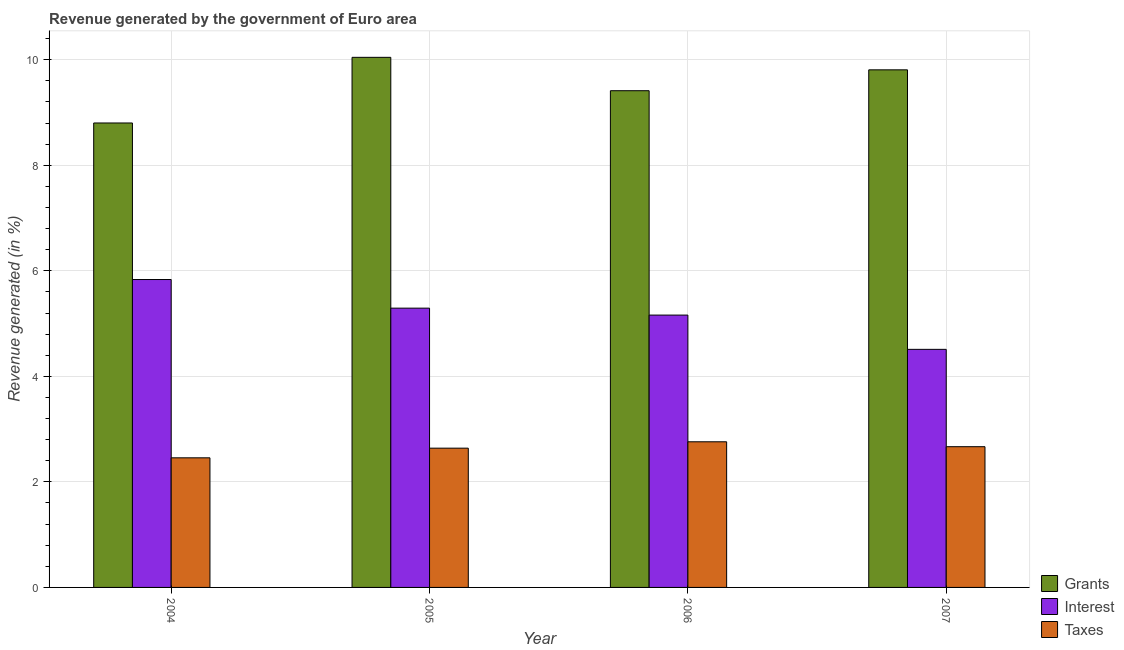What is the label of the 2nd group of bars from the left?
Make the answer very short. 2005. In how many cases, is the number of bars for a given year not equal to the number of legend labels?
Keep it short and to the point. 0. What is the percentage of revenue generated by taxes in 2004?
Provide a succinct answer. 2.46. Across all years, what is the maximum percentage of revenue generated by taxes?
Offer a very short reply. 2.76. Across all years, what is the minimum percentage of revenue generated by interest?
Make the answer very short. 4.51. In which year was the percentage of revenue generated by taxes maximum?
Ensure brevity in your answer.  2006. What is the total percentage of revenue generated by taxes in the graph?
Offer a terse response. 10.52. What is the difference between the percentage of revenue generated by interest in 2004 and that in 2005?
Your response must be concise. 0.54. What is the difference between the percentage of revenue generated by taxes in 2007 and the percentage of revenue generated by grants in 2005?
Your answer should be very brief. 0.03. What is the average percentage of revenue generated by interest per year?
Provide a succinct answer. 5.2. In the year 2005, what is the difference between the percentage of revenue generated by taxes and percentage of revenue generated by grants?
Keep it short and to the point. 0. What is the ratio of the percentage of revenue generated by taxes in 2004 to that in 2005?
Provide a succinct answer. 0.93. Is the percentage of revenue generated by grants in 2004 less than that in 2006?
Provide a succinct answer. Yes. Is the difference between the percentage of revenue generated by interest in 2006 and 2007 greater than the difference between the percentage of revenue generated by taxes in 2006 and 2007?
Your response must be concise. No. What is the difference between the highest and the second highest percentage of revenue generated by interest?
Provide a short and direct response. 0.54. What is the difference between the highest and the lowest percentage of revenue generated by interest?
Your response must be concise. 1.32. In how many years, is the percentage of revenue generated by interest greater than the average percentage of revenue generated by interest taken over all years?
Keep it short and to the point. 2. Is the sum of the percentage of revenue generated by taxes in 2005 and 2006 greater than the maximum percentage of revenue generated by interest across all years?
Give a very brief answer. Yes. What does the 1st bar from the left in 2005 represents?
Your response must be concise. Grants. What does the 2nd bar from the right in 2007 represents?
Ensure brevity in your answer.  Interest. How many bars are there?
Keep it short and to the point. 12. Are all the bars in the graph horizontal?
Your response must be concise. No. How many years are there in the graph?
Your answer should be compact. 4. What is the difference between two consecutive major ticks on the Y-axis?
Your answer should be compact. 2. Are the values on the major ticks of Y-axis written in scientific E-notation?
Make the answer very short. No. Does the graph contain any zero values?
Give a very brief answer. No. Does the graph contain grids?
Give a very brief answer. Yes. How are the legend labels stacked?
Your response must be concise. Vertical. What is the title of the graph?
Keep it short and to the point. Revenue generated by the government of Euro area. What is the label or title of the Y-axis?
Keep it short and to the point. Revenue generated (in %). What is the Revenue generated (in %) of Grants in 2004?
Offer a very short reply. 8.8. What is the Revenue generated (in %) of Interest in 2004?
Offer a terse response. 5.84. What is the Revenue generated (in %) in Taxes in 2004?
Your answer should be very brief. 2.46. What is the Revenue generated (in %) of Grants in 2005?
Offer a terse response. 10.05. What is the Revenue generated (in %) in Interest in 2005?
Provide a short and direct response. 5.29. What is the Revenue generated (in %) in Taxes in 2005?
Your answer should be very brief. 2.64. What is the Revenue generated (in %) in Grants in 2006?
Your response must be concise. 9.41. What is the Revenue generated (in %) of Interest in 2006?
Your answer should be very brief. 5.16. What is the Revenue generated (in %) in Taxes in 2006?
Provide a short and direct response. 2.76. What is the Revenue generated (in %) of Grants in 2007?
Make the answer very short. 9.81. What is the Revenue generated (in %) of Interest in 2007?
Give a very brief answer. 4.51. What is the Revenue generated (in %) of Taxes in 2007?
Make the answer very short. 2.67. Across all years, what is the maximum Revenue generated (in %) in Grants?
Ensure brevity in your answer.  10.05. Across all years, what is the maximum Revenue generated (in %) in Interest?
Give a very brief answer. 5.84. Across all years, what is the maximum Revenue generated (in %) in Taxes?
Make the answer very short. 2.76. Across all years, what is the minimum Revenue generated (in %) in Grants?
Offer a very short reply. 8.8. Across all years, what is the minimum Revenue generated (in %) of Interest?
Offer a very short reply. 4.51. Across all years, what is the minimum Revenue generated (in %) in Taxes?
Your answer should be very brief. 2.46. What is the total Revenue generated (in %) in Grants in the graph?
Ensure brevity in your answer.  38.07. What is the total Revenue generated (in %) of Interest in the graph?
Give a very brief answer. 20.8. What is the total Revenue generated (in %) in Taxes in the graph?
Ensure brevity in your answer.  10.52. What is the difference between the Revenue generated (in %) in Grants in 2004 and that in 2005?
Ensure brevity in your answer.  -1.24. What is the difference between the Revenue generated (in %) of Interest in 2004 and that in 2005?
Your answer should be compact. 0.54. What is the difference between the Revenue generated (in %) of Taxes in 2004 and that in 2005?
Give a very brief answer. -0.18. What is the difference between the Revenue generated (in %) in Grants in 2004 and that in 2006?
Offer a very short reply. -0.61. What is the difference between the Revenue generated (in %) in Interest in 2004 and that in 2006?
Make the answer very short. 0.67. What is the difference between the Revenue generated (in %) of Taxes in 2004 and that in 2006?
Ensure brevity in your answer.  -0.3. What is the difference between the Revenue generated (in %) in Grants in 2004 and that in 2007?
Offer a terse response. -1.01. What is the difference between the Revenue generated (in %) of Interest in 2004 and that in 2007?
Your response must be concise. 1.32. What is the difference between the Revenue generated (in %) of Taxes in 2004 and that in 2007?
Give a very brief answer. -0.21. What is the difference between the Revenue generated (in %) in Grants in 2005 and that in 2006?
Make the answer very short. 0.63. What is the difference between the Revenue generated (in %) of Interest in 2005 and that in 2006?
Offer a terse response. 0.13. What is the difference between the Revenue generated (in %) of Taxes in 2005 and that in 2006?
Offer a very short reply. -0.12. What is the difference between the Revenue generated (in %) in Grants in 2005 and that in 2007?
Provide a succinct answer. 0.24. What is the difference between the Revenue generated (in %) of Interest in 2005 and that in 2007?
Your answer should be compact. 0.78. What is the difference between the Revenue generated (in %) in Taxes in 2005 and that in 2007?
Provide a short and direct response. -0.03. What is the difference between the Revenue generated (in %) in Grants in 2006 and that in 2007?
Provide a succinct answer. -0.4. What is the difference between the Revenue generated (in %) in Interest in 2006 and that in 2007?
Offer a very short reply. 0.65. What is the difference between the Revenue generated (in %) in Taxes in 2006 and that in 2007?
Your answer should be very brief. 0.09. What is the difference between the Revenue generated (in %) in Grants in 2004 and the Revenue generated (in %) in Interest in 2005?
Your answer should be compact. 3.51. What is the difference between the Revenue generated (in %) in Grants in 2004 and the Revenue generated (in %) in Taxes in 2005?
Offer a very short reply. 6.16. What is the difference between the Revenue generated (in %) of Interest in 2004 and the Revenue generated (in %) of Taxes in 2005?
Offer a terse response. 3.2. What is the difference between the Revenue generated (in %) of Grants in 2004 and the Revenue generated (in %) of Interest in 2006?
Provide a succinct answer. 3.64. What is the difference between the Revenue generated (in %) in Grants in 2004 and the Revenue generated (in %) in Taxes in 2006?
Provide a short and direct response. 6.04. What is the difference between the Revenue generated (in %) of Interest in 2004 and the Revenue generated (in %) of Taxes in 2006?
Offer a very short reply. 3.08. What is the difference between the Revenue generated (in %) of Grants in 2004 and the Revenue generated (in %) of Interest in 2007?
Ensure brevity in your answer.  4.29. What is the difference between the Revenue generated (in %) in Grants in 2004 and the Revenue generated (in %) in Taxes in 2007?
Provide a succinct answer. 6.13. What is the difference between the Revenue generated (in %) of Interest in 2004 and the Revenue generated (in %) of Taxes in 2007?
Ensure brevity in your answer.  3.17. What is the difference between the Revenue generated (in %) of Grants in 2005 and the Revenue generated (in %) of Interest in 2006?
Offer a very short reply. 4.88. What is the difference between the Revenue generated (in %) of Grants in 2005 and the Revenue generated (in %) of Taxes in 2006?
Provide a succinct answer. 7.29. What is the difference between the Revenue generated (in %) in Interest in 2005 and the Revenue generated (in %) in Taxes in 2006?
Your answer should be very brief. 2.53. What is the difference between the Revenue generated (in %) in Grants in 2005 and the Revenue generated (in %) in Interest in 2007?
Provide a succinct answer. 5.53. What is the difference between the Revenue generated (in %) of Grants in 2005 and the Revenue generated (in %) of Taxes in 2007?
Provide a succinct answer. 7.38. What is the difference between the Revenue generated (in %) in Interest in 2005 and the Revenue generated (in %) in Taxes in 2007?
Your response must be concise. 2.63. What is the difference between the Revenue generated (in %) of Grants in 2006 and the Revenue generated (in %) of Interest in 2007?
Offer a terse response. 4.9. What is the difference between the Revenue generated (in %) of Grants in 2006 and the Revenue generated (in %) of Taxes in 2007?
Keep it short and to the point. 6.75. What is the difference between the Revenue generated (in %) of Interest in 2006 and the Revenue generated (in %) of Taxes in 2007?
Your answer should be very brief. 2.49. What is the average Revenue generated (in %) of Grants per year?
Keep it short and to the point. 9.52. What is the average Revenue generated (in %) of Interest per year?
Offer a very short reply. 5.2. What is the average Revenue generated (in %) in Taxes per year?
Keep it short and to the point. 2.63. In the year 2004, what is the difference between the Revenue generated (in %) in Grants and Revenue generated (in %) in Interest?
Your answer should be compact. 2.97. In the year 2004, what is the difference between the Revenue generated (in %) of Grants and Revenue generated (in %) of Taxes?
Keep it short and to the point. 6.35. In the year 2004, what is the difference between the Revenue generated (in %) in Interest and Revenue generated (in %) in Taxes?
Your response must be concise. 3.38. In the year 2005, what is the difference between the Revenue generated (in %) in Grants and Revenue generated (in %) in Interest?
Your answer should be very brief. 4.75. In the year 2005, what is the difference between the Revenue generated (in %) of Grants and Revenue generated (in %) of Taxes?
Keep it short and to the point. 7.41. In the year 2005, what is the difference between the Revenue generated (in %) in Interest and Revenue generated (in %) in Taxes?
Provide a short and direct response. 2.65. In the year 2006, what is the difference between the Revenue generated (in %) of Grants and Revenue generated (in %) of Interest?
Keep it short and to the point. 4.25. In the year 2006, what is the difference between the Revenue generated (in %) in Grants and Revenue generated (in %) in Taxes?
Your answer should be very brief. 6.65. In the year 2006, what is the difference between the Revenue generated (in %) of Interest and Revenue generated (in %) of Taxes?
Your answer should be very brief. 2.4. In the year 2007, what is the difference between the Revenue generated (in %) in Grants and Revenue generated (in %) in Interest?
Make the answer very short. 5.3. In the year 2007, what is the difference between the Revenue generated (in %) of Grants and Revenue generated (in %) of Taxes?
Keep it short and to the point. 7.14. In the year 2007, what is the difference between the Revenue generated (in %) in Interest and Revenue generated (in %) in Taxes?
Give a very brief answer. 1.84. What is the ratio of the Revenue generated (in %) in Grants in 2004 to that in 2005?
Make the answer very short. 0.88. What is the ratio of the Revenue generated (in %) in Interest in 2004 to that in 2005?
Offer a terse response. 1.1. What is the ratio of the Revenue generated (in %) in Taxes in 2004 to that in 2005?
Ensure brevity in your answer.  0.93. What is the ratio of the Revenue generated (in %) of Grants in 2004 to that in 2006?
Your answer should be very brief. 0.94. What is the ratio of the Revenue generated (in %) in Interest in 2004 to that in 2006?
Keep it short and to the point. 1.13. What is the ratio of the Revenue generated (in %) in Taxes in 2004 to that in 2006?
Offer a very short reply. 0.89. What is the ratio of the Revenue generated (in %) in Grants in 2004 to that in 2007?
Give a very brief answer. 0.9. What is the ratio of the Revenue generated (in %) in Interest in 2004 to that in 2007?
Offer a very short reply. 1.29. What is the ratio of the Revenue generated (in %) in Taxes in 2004 to that in 2007?
Provide a short and direct response. 0.92. What is the ratio of the Revenue generated (in %) of Grants in 2005 to that in 2006?
Offer a very short reply. 1.07. What is the ratio of the Revenue generated (in %) in Interest in 2005 to that in 2006?
Ensure brevity in your answer.  1.03. What is the ratio of the Revenue generated (in %) in Taxes in 2005 to that in 2006?
Make the answer very short. 0.96. What is the ratio of the Revenue generated (in %) in Grants in 2005 to that in 2007?
Ensure brevity in your answer.  1.02. What is the ratio of the Revenue generated (in %) of Interest in 2005 to that in 2007?
Your answer should be compact. 1.17. What is the ratio of the Revenue generated (in %) in Grants in 2006 to that in 2007?
Keep it short and to the point. 0.96. What is the ratio of the Revenue generated (in %) in Interest in 2006 to that in 2007?
Make the answer very short. 1.14. What is the ratio of the Revenue generated (in %) of Taxes in 2006 to that in 2007?
Your response must be concise. 1.03. What is the difference between the highest and the second highest Revenue generated (in %) of Grants?
Provide a short and direct response. 0.24. What is the difference between the highest and the second highest Revenue generated (in %) in Interest?
Provide a succinct answer. 0.54. What is the difference between the highest and the second highest Revenue generated (in %) in Taxes?
Give a very brief answer. 0.09. What is the difference between the highest and the lowest Revenue generated (in %) of Grants?
Offer a terse response. 1.24. What is the difference between the highest and the lowest Revenue generated (in %) of Interest?
Keep it short and to the point. 1.32. What is the difference between the highest and the lowest Revenue generated (in %) in Taxes?
Ensure brevity in your answer.  0.3. 